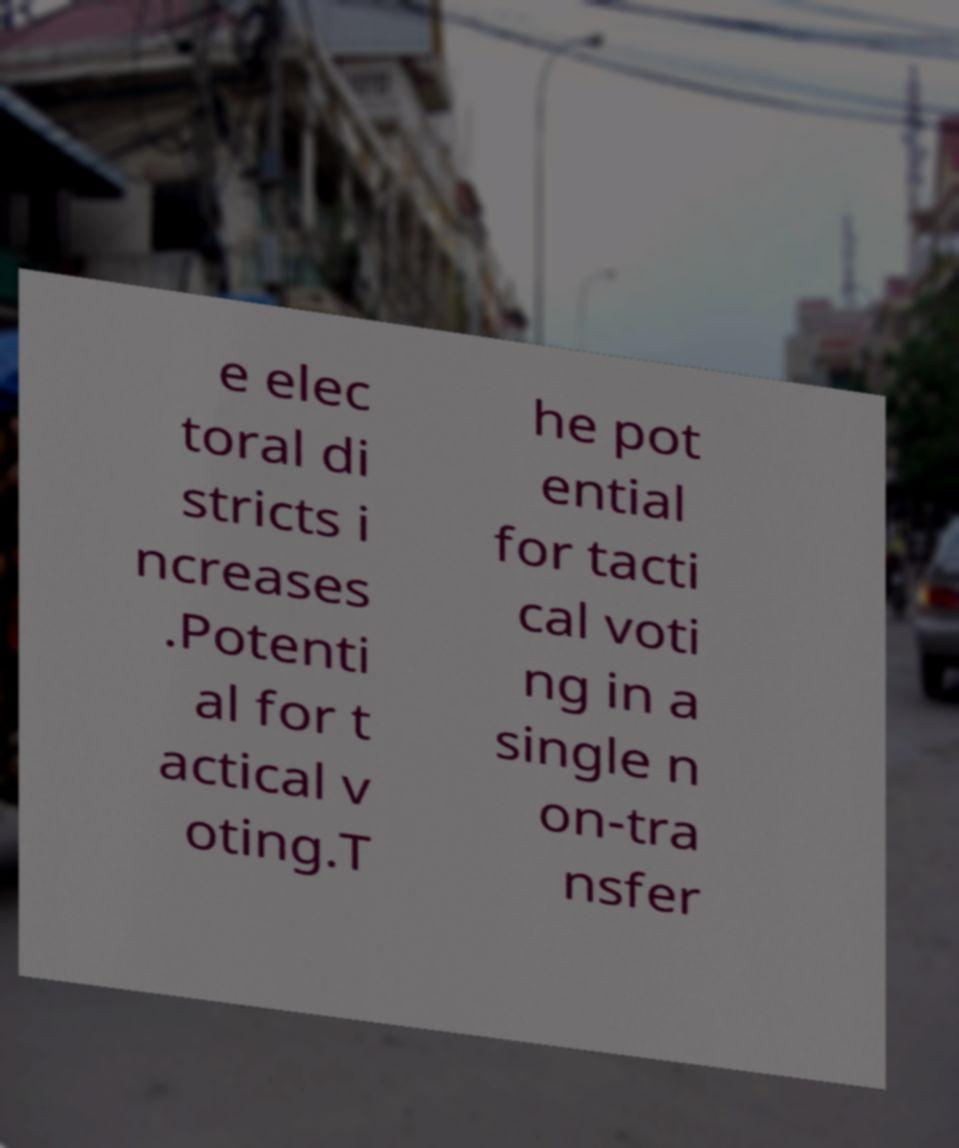What messages or text are displayed in this image? I need them in a readable, typed format. e elec toral di stricts i ncreases .Potenti al for t actical v oting.T he pot ential for tacti cal voti ng in a single n on-tra nsfer 